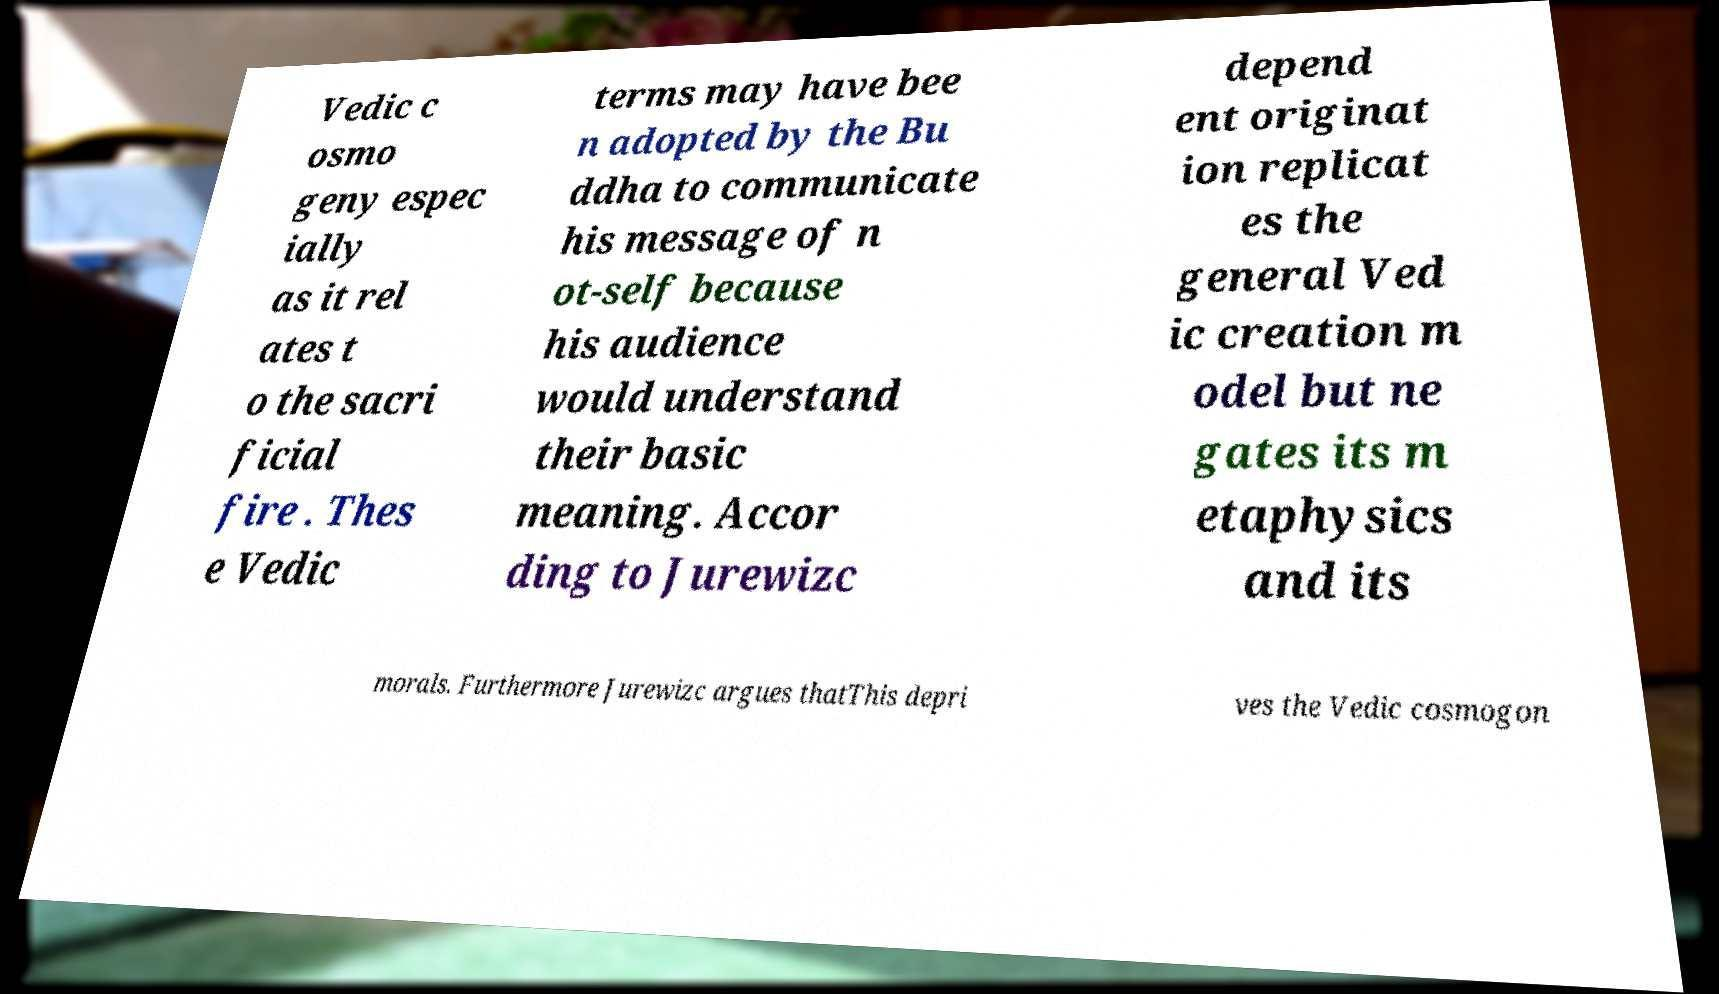Can you accurately transcribe the text from the provided image for me? Vedic c osmo geny espec ially as it rel ates t o the sacri ficial fire . Thes e Vedic terms may have bee n adopted by the Bu ddha to communicate his message of n ot-self because his audience would understand their basic meaning. Accor ding to Jurewizc depend ent originat ion replicat es the general Ved ic creation m odel but ne gates its m etaphysics and its morals. Furthermore Jurewizc argues thatThis depri ves the Vedic cosmogon 